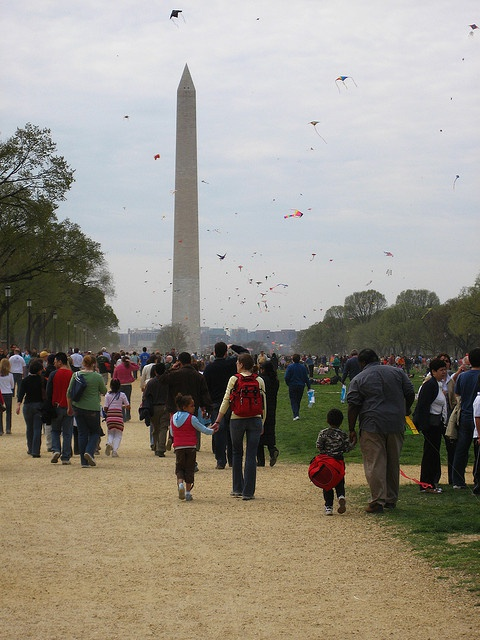Describe the objects in this image and their specific colors. I can see people in lightgray, black, gray, tan, and darkgreen tones, kite in lightgray, darkgray, and gray tones, people in lightgray, black, gray, and darkgreen tones, people in lightgray, black, gray, maroon, and darkgreen tones, and people in lightgray, black, maroon, tan, and olive tones in this image. 